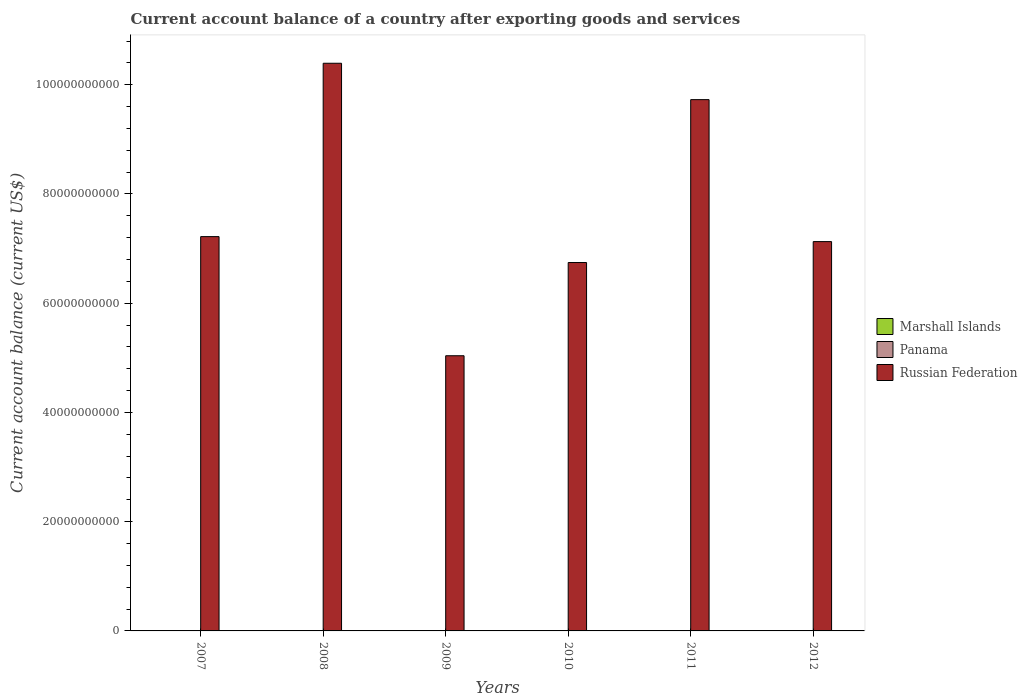How many different coloured bars are there?
Give a very brief answer. 1. How many bars are there on the 6th tick from the left?
Ensure brevity in your answer.  1. What is the label of the 6th group of bars from the left?
Provide a succinct answer. 2012. In how many cases, is the number of bars for a given year not equal to the number of legend labels?
Provide a succinct answer. 6. What is the account balance in Marshall Islands in 2012?
Your answer should be very brief. 0. Across all years, what is the maximum account balance in Russian Federation?
Keep it short and to the point. 1.04e+11. In which year was the account balance in Russian Federation maximum?
Ensure brevity in your answer.  2008. What is the total account balance in Russian Federation in the graph?
Provide a short and direct response. 4.63e+11. What is the difference between the account balance in Russian Federation in 2008 and that in 2010?
Ensure brevity in your answer.  3.65e+1. What is the difference between the account balance in Russian Federation in 2007 and the account balance in Marshall Islands in 2009?
Your response must be concise. 7.22e+1. In how many years, is the account balance in Russian Federation greater than 44000000000 US$?
Ensure brevity in your answer.  6. What is the ratio of the account balance in Russian Federation in 2008 to that in 2011?
Your answer should be very brief. 1.07. Is the account balance in Russian Federation in 2009 less than that in 2012?
Provide a succinct answer. Yes. What is the difference between the highest and the second highest account balance in Russian Federation?
Provide a short and direct response. 6.66e+09. What is the difference between the highest and the lowest account balance in Russian Federation?
Make the answer very short. 5.36e+1. In how many years, is the account balance in Panama greater than the average account balance in Panama taken over all years?
Your answer should be compact. 0. Is the sum of the account balance in Russian Federation in 2008 and 2010 greater than the maximum account balance in Panama across all years?
Provide a short and direct response. Yes. Is it the case that in every year, the sum of the account balance in Marshall Islands and account balance in Russian Federation is greater than the account balance in Panama?
Provide a succinct answer. Yes. What is the difference between two consecutive major ticks on the Y-axis?
Offer a terse response. 2.00e+1. Does the graph contain grids?
Ensure brevity in your answer.  No. How many legend labels are there?
Give a very brief answer. 3. How are the legend labels stacked?
Offer a terse response. Vertical. What is the title of the graph?
Make the answer very short. Current account balance of a country after exporting goods and services. Does "Somalia" appear as one of the legend labels in the graph?
Give a very brief answer. No. What is the label or title of the X-axis?
Offer a very short reply. Years. What is the label or title of the Y-axis?
Offer a very short reply. Current account balance (current US$). What is the Current account balance (current US$) of Marshall Islands in 2007?
Offer a terse response. 0. What is the Current account balance (current US$) of Panama in 2007?
Provide a succinct answer. 0. What is the Current account balance (current US$) in Russian Federation in 2007?
Offer a very short reply. 7.22e+1. What is the Current account balance (current US$) in Russian Federation in 2008?
Offer a very short reply. 1.04e+11. What is the Current account balance (current US$) of Marshall Islands in 2009?
Keep it short and to the point. 0. What is the Current account balance (current US$) in Panama in 2009?
Offer a very short reply. 0. What is the Current account balance (current US$) of Russian Federation in 2009?
Provide a short and direct response. 5.04e+1. What is the Current account balance (current US$) in Marshall Islands in 2010?
Provide a succinct answer. 0. What is the Current account balance (current US$) in Russian Federation in 2010?
Make the answer very short. 6.75e+1. What is the Current account balance (current US$) in Panama in 2011?
Give a very brief answer. 0. What is the Current account balance (current US$) of Russian Federation in 2011?
Ensure brevity in your answer.  9.73e+1. What is the Current account balance (current US$) in Panama in 2012?
Provide a succinct answer. 0. What is the Current account balance (current US$) of Russian Federation in 2012?
Make the answer very short. 7.13e+1. Across all years, what is the maximum Current account balance (current US$) of Russian Federation?
Your response must be concise. 1.04e+11. Across all years, what is the minimum Current account balance (current US$) in Russian Federation?
Keep it short and to the point. 5.04e+1. What is the total Current account balance (current US$) of Russian Federation in the graph?
Make the answer very short. 4.63e+11. What is the difference between the Current account balance (current US$) of Russian Federation in 2007 and that in 2008?
Offer a terse response. -3.17e+1. What is the difference between the Current account balance (current US$) in Russian Federation in 2007 and that in 2009?
Make the answer very short. 2.18e+1. What is the difference between the Current account balance (current US$) of Russian Federation in 2007 and that in 2010?
Provide a succinct answer. 4.74e+09. What is the difference between the Current account balance (current US$) of Russian Federation in 2007 and that in 2011?
Make the answer very short. -2.51e+1. What is the difference between the Current account balance (current US$) in Russian Federation in 2007 and that in 2012?
Provide a short and direct response. 9.11e+08. What is the difference between the Current account balance (current US$) of Russian Federation in 2008 and that in 2009?
Offer a terse response. 5.36e+1. What is the difference between the Current account balance (current US$) in Russian Federation in 2008 and that in 2010?
Give a very brief answer. 3.65e+1. What is the difference between the Current account balance (current US$) in Russian Federation in 2008 and that in 2011?
Give a very brief answer. 6.66e+09. What is the difference between the Current account balance (current US$) in Russian Federation in 2008 and that in 2012?
Provide a short and direct response. 3.27e+1. What is the difference between the Current account balance (current US$) of Russian Federation in 2009 and that in 2010?
Provide a succinct answer. -1.71e+1. What is the difference between the Current account balance (current US$) in Russian Federation in 2009 and that in 2011?
Your answer should be compact. -4.69e+1. What is the difference between the Current account balance (current US$) of Russian Federation in 2009 and that in 2012?
Your answer should be very brief. -2.09e+1. What is the difference between the Current account balance (current US$) in Russian Federation in 2010 and that in 2011?
Keep it short and to the point. -2.98e+1. What is the difference between the Current account balance (current US$) of Russian Federation in 2010 and that in 2012?
Ensure brevity in your answer.  -3.83e+09. What is the difference between the Current account balance (current US$) of Russian Federation in 2011 and that in 2012?
Your answer should be very brief. 2.60e+1. What is the average Current account balance (current US$) of Marshall Islands per year?
Offer a terse response. 0. What is the average Current account balance (current US$) in Panama per year?
Provide a succinct answer. 0. What is the average Current account balance (current US$) of Russian Federation per year?
Provide a short and direct response. 7.71e+1. What is the ratio of the Current account balance (current US$) in Russian Federation in 2007 to that in 2008?
Offer a terse response. 0.69. What is the ratio of the Current account balance (current US$) of Russian Federation in 2007 to that in 2009?
Provide a succinct answer. 1.43. What is the ratio of the Current account balance (current US$) in Russian Federation in 2007 to that in 2010?
Provide a short and direct response. 1.07. What is the ratio of the Current account balance (current US$) of Russian Federation in 2007 to that in 2011?
Offer a terse response. 0.74. What is the ratio of the Current account balance (current US$) in Russian Federation in 2007 to that in 2012?
Ensure brevity in your answer.  1.01. What is the ratio of the Current account balance (current US$) in Russian Federation in 2008 to that in 2009?
Provide a succinct answer. 2.06. What is the ratio of the Current account balance (current US$) of Russian Federation in 2008 to that in 2010?
Give a very brief answer. 1.54. What is the ratio of the Current account balance (current US$) in Russian Federation in 2008 to that in 2011?
Ensure brevity in your answer.  1.07. What is the ratio of the Current account balance (current US$) of Russian Federation in 2008 to that in 2012?
Offer a terse response. 1.46. What is the ratio of the Current account balance (current US$) of Russian Federation in 2009 to that in 2010?
Give a very brief answer. 0.75. What is the ratio of the Current account balance (current US$) of Russian Federation in 2009 to that in 2011?
Your answer should be compact. 0.52. What is the ratio of the Current account balance (current US$) in Russian Federation in 2009 to that in 2012?
Your answer should be very brief. 0.71. What is the ratio of the Current account balance (current US$) of Russian Federation in 2010 to that in 2011?
Your answer should be very brief. 0.69. What is the ratio of the Current account balance (current US$) in Russian Federation in 2010 to that in 2012?
Provide a succinct answer. 0.95. What is the ratio of the Current account balance (current US$) in Russian Federation in 2011 to that in 2012?
Offer a terse response. 1.36. What is the difference between the highest and the second highest Current account balance (current US$) of Russian Federation?
Provide a short and direct response. 6.66e+09. What is the difference between the highest and the lowest Current account balance (current US$) of Russian Federation?
Offer a terse response. 5.36e+1. 